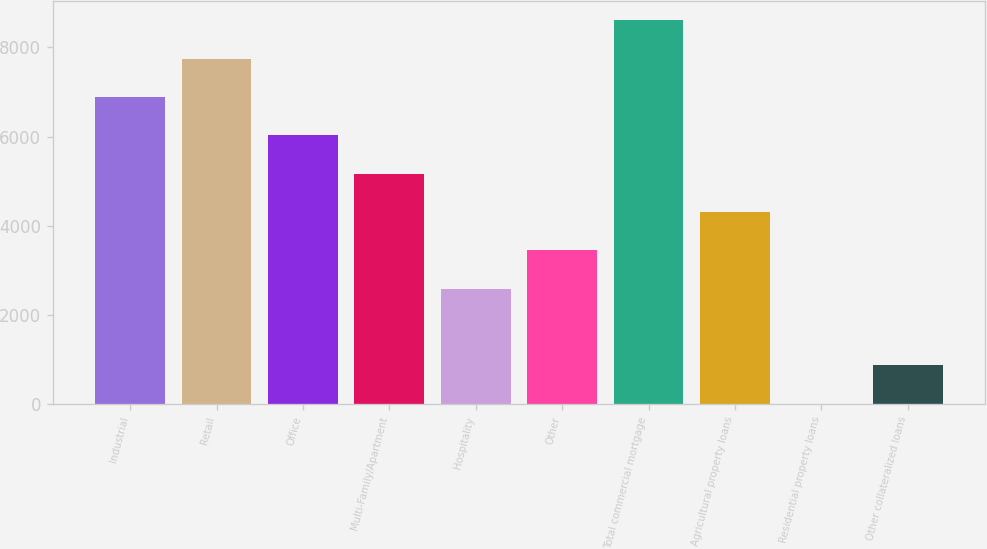<chart> <loc_0><loc_0><loc_500><loc_500><bar_chart><fcel>Industrial<fcel>Retail<fcel>Office<fcel>Multi-Family/Apartment<fcel>Hospitality<fcel>Other<fcel>Total commercial mortgage<fcel>Agricultural property loans<fcel>Residential property loans<fcel>Other collateralized loans<nl><fcel>6887.4<fcel>7748.2<fcel>6026.6<fcel>5165.8<fcel>2583.4<fcel>3444.2<fcel>8609<fcel>4305<fcel>1<fcel>861.8<nl></chart> 